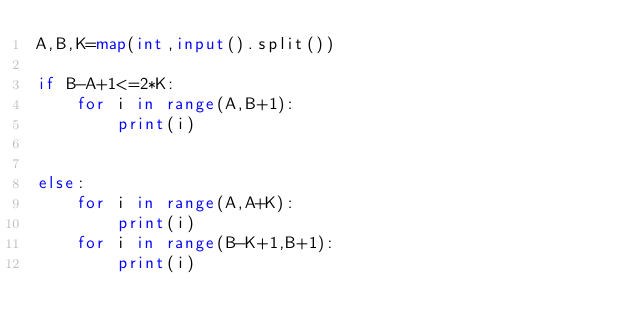Convert code to text. <code><loc_0><loc_0><loc_500><loc_500><_Python_>A,B,K=map(int,input().split())

if B-A+1<=2*K:
    for i in range(A,B+1):
        print(i)


else:
    for i in range(A,A+K):
        print(i)
    for i in range(B-K+1,B+1):
        print(i)</code> 